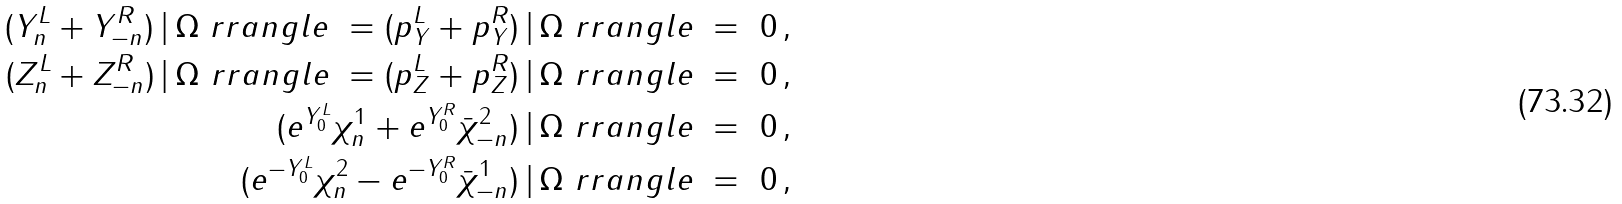<formula> <loc_0><loc_0><loc_500><loc_500>( Y _ { n } ^ { L } + Y ^ { R } _ { - n } ) \, | \, \Omega \ r r a n g l e \ = ( p _ { Y } ^ { L } + p ^ { R } _ { Y } ) \, | \, \Omega \ r r a n g l e \ = \ 0 \, , \\ ( Z _ { n } ^ { L } + Z ^ { R } _ { - n } ) \, | \, \Omega \ r r a n g l e \ = ( p _ { Z } ^ { L } + p ^ { R } _ { Z } ) \, | \, \Omega \ r r a n g l e \ = \ 0 \, , \\ ( e ^ { Y _ { 0 } ^ { L } } \chi ^ { 1 } _ { n } + e ^ { Y _ { 0 } ^ { R } } \bar { \chi } ^ { 2 } _ { - n } ) \, | \, \Omega \ r r a n g l e \ = \ 0 \, , \\ ( e ^ { - Y _ { 0 } ^ { L } } \chi ^ { 2 } _ { n } - e ^ { - Y _ { 0 } ^ { R } } \bar { \chi } ^ { 1 } _ { - n } ) \, | \, \Omega \ r r a n g l e \ = \ 0 \, , \\</formula> 